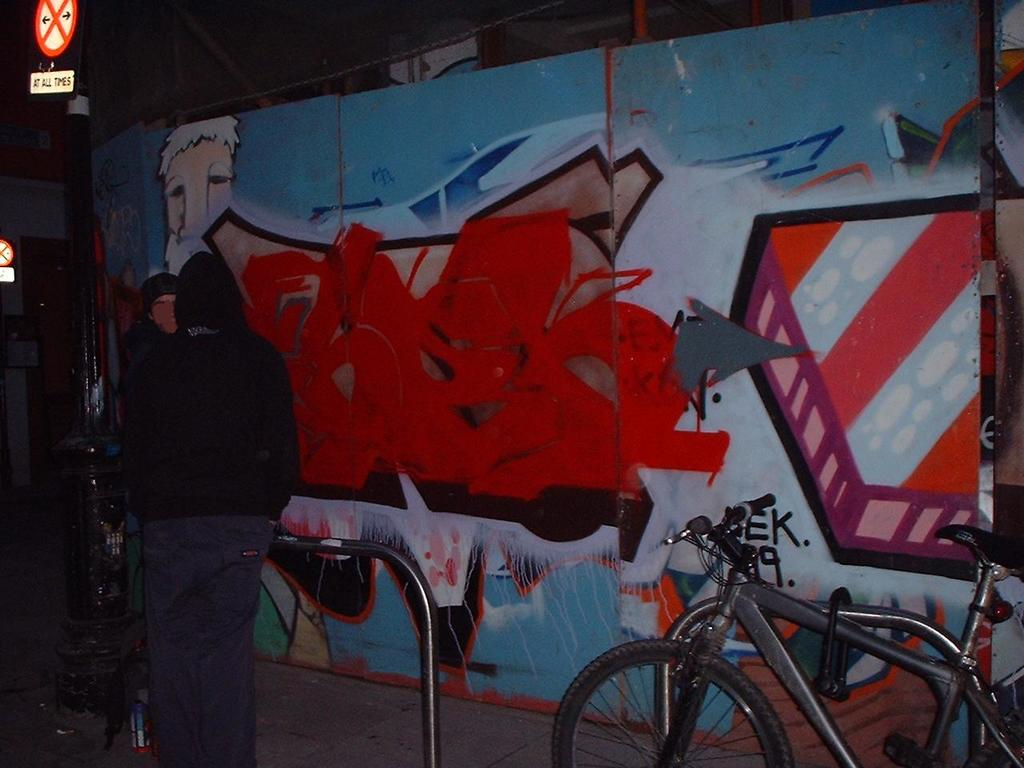What is the main subject in the image? There is a person standing in the image. What object is also visible in the image? There is a bicycle in the image. What type of signage can be seen in the image? Sign boards are present in the image. What structural elements are visible in the image? Poles are visible in the image. How would you describe the appearance of the wall in the image? The wall has a colorful appearance. What type of metal is used to make the jelly in the image? There is no jelly present in the image, and therefore no metal or jelly can be observed. What type of fiction is being read by the person in the image? There is no indication in the image that the person is reading any fiction. 